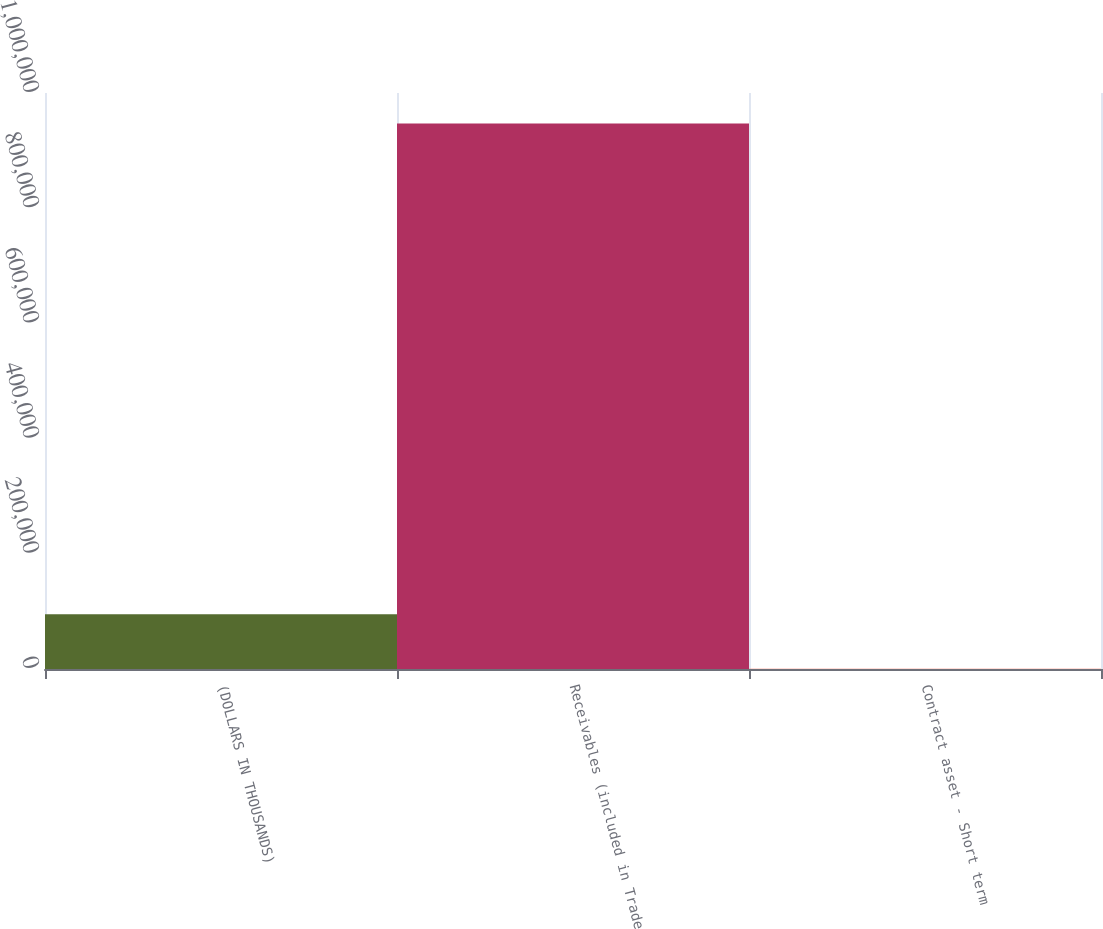Convert chart. <chart><loc_0><loc_0><loc_500><loc_500><bar_chart><fcel>(DOLLARS IN THOUSANDS)<fcel>Receivables (included in Trade<fcel>Contract asset - Short term<nl><fcel>95132.1<fcel>946938<fcel>487<nl></chart> 